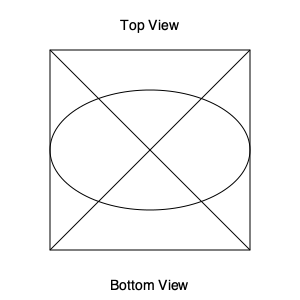Looking at the top and bottom views of an irregular 3D object shown in the diagram, estimate its volume if the cube enclosing it has sides of 10 cm each. The ellipse in the middle represents the widest part of the object. Let's approach this step-by-step:

1. The cube enclosing the object has a volume of $10 \times 10 \times 10 = 1000$ cm³.

2. The object is irregular, but we can approximate it as an ellipsoid for estimation.

3. The formula for the volume of an ellipsoid is $V = \frac{4}{3}\pi abc$, where $a$, $b$, and $c$ are the semi-axes.

4. From the top view, we can see that the maximum width and length of the object are less than the cube's sides. Let's estimate them as 8 cm each.

5. The height of the object appears to be close to the cube's height, so let's estimate it as 9 cm.

6. Therefore, $a = 4$ cm, $b = 4$ cm, and $c = 4.5$ cm.

7. Plugging these into the formula:
   $V \approx \frac{4}{3}\pi (4)(4)(4.5) \approx 301.59$ cm³

8. Rounding this to a reasonable estimate, we get about 300 cm³.

9. This is approximately 30% of the enclosing cube's volume, which seems reasonable given the shape shown in the diagram.
Answer: Approximately 300 cm³ 